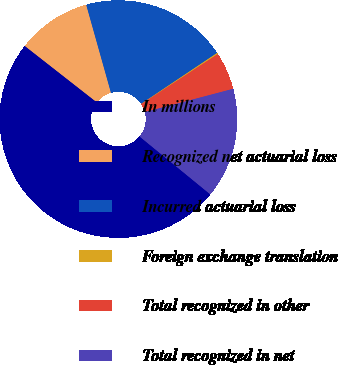Convert chart. <chart><loc_0><loc_0><loc_500><loc_500><pie_chart><fcel>In millions<fcel>Recognized net actuarial loss<fcel>Incurred actuarial loss<fcel>Foreign exchange translation<fcel>Total recognized in other<fcel>Total recognized in net<nl><fcel>49.66%<fcel>10.07%<fcel>19.97%<fcel>0.17%<fcel>5.12%<fcel>15.02%<nl></chart> 